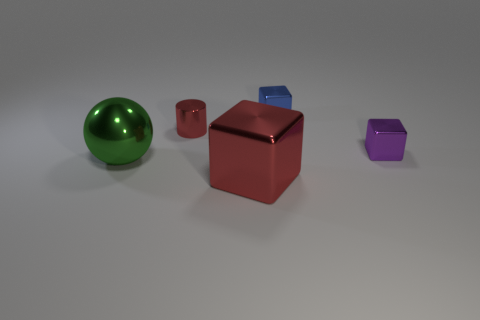What number of cubes are green things or big shiny objects?
Your answer should be very brief. 1. There is a big metallic object to the right of the large green shiny sphere; is there a large metallic thing behind it?
Provide a short and direct response. Yes. Does the blue thing have the same shape as the large red object that is on the left side of the purple shiny object?
Your answer should be compact. Yes. How many other objects are there of the same size as the red cylinder?
Your response must be concise. 2. How many gray things are big objects or metal objects?
Offer a terse response. 0. How many shiny objects are both behind the green metallic sphere and to the right of the tiny red metallic cylinder?
Your response must be concise. 2. How many large cyan cylinders are made of the same material as the blue thing?
Make the answer very short. 0. What shape is the object that is the same color as the metallic cylinder?
Ensure brevity in your answer.  Cube. There is a metal object that is the same size as the green metal ball; what shape is it?
Provide a short and direct response. Cube. There is a tiny purple block; are there any large cubes in front of it?
Offer a terse response. Yes. 